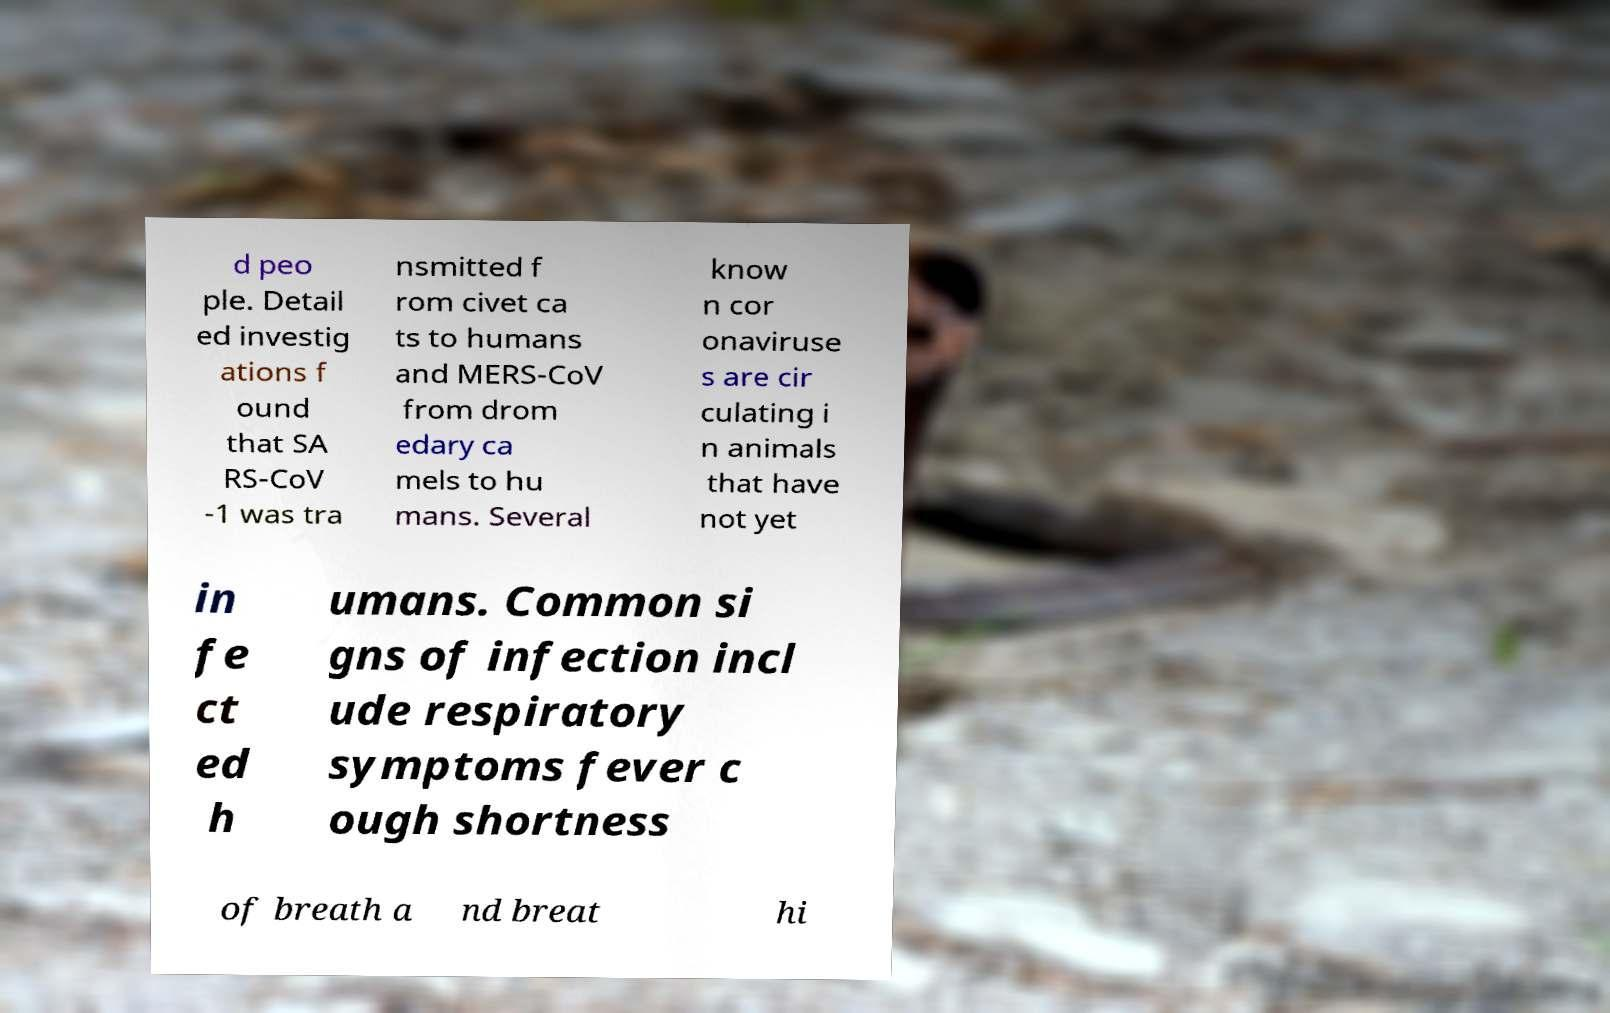I need the written content from this picture converted into text. Can you do that? d peo ple. Detail ed investig ations f ound that SA RS-CoV -1 was tra nsmitted f rom civet ca ts to humans and MERS-CoV from drom edary ca mels to hu mans. Several know n cor onaviruse s are cir culating i n animals that have not yet in fe ct ed h umans. Common si gns of infection incl ude respiratory symptoms fever c ough shortness of breath a nd breat hi 